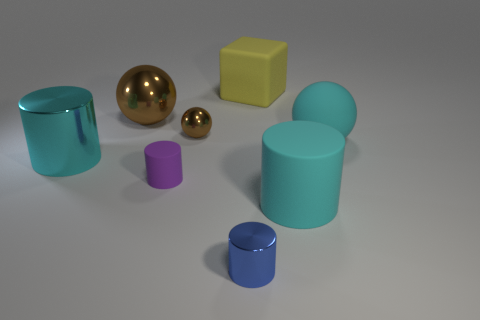Add 2 large brown cylinders. How many objects exist? 10 Subtract all blocks. How many objects are left? 7 Subtract all small blue metal objects. Subtract all large yellow things. How many objects are left? 6 Add 3 yellow rubber objects. How many yellow rubber objects are left? 4 Add 6 big matte things. How many big matte things exist? 9 Subtract 0 gray cubes. How many objects are left? 8 